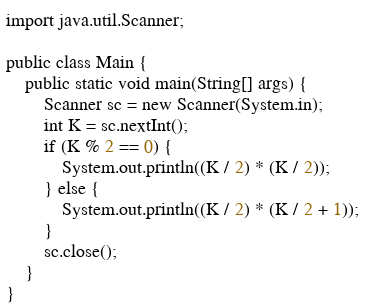<code> <loc_0><loc_0><loc_500><loc_500><_Java_>import java.util.Scanner;

public class Main {
    public static void main(String[] args) {
        Scanner sc = new Scanner(System.in);
        int K = sc.nextInt();
        if (K % 2 == 0) {
            System.out.println((K / 2) * (K / 2));
        } else {
            System.out.println((K / 2) * (K / 2 + 1));
        }
        sc.close();
    }
}</code> 